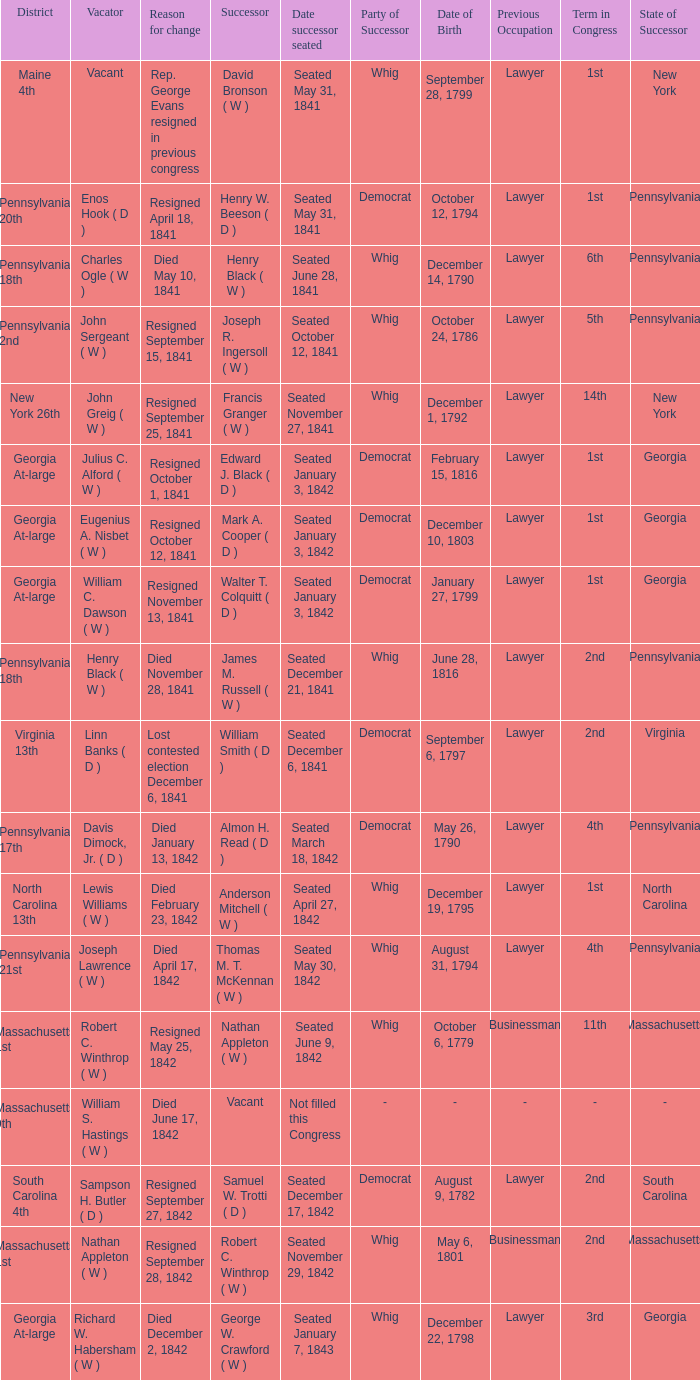Name the date successor seated for pennsylvania 17th Seated March 18, 1842. 